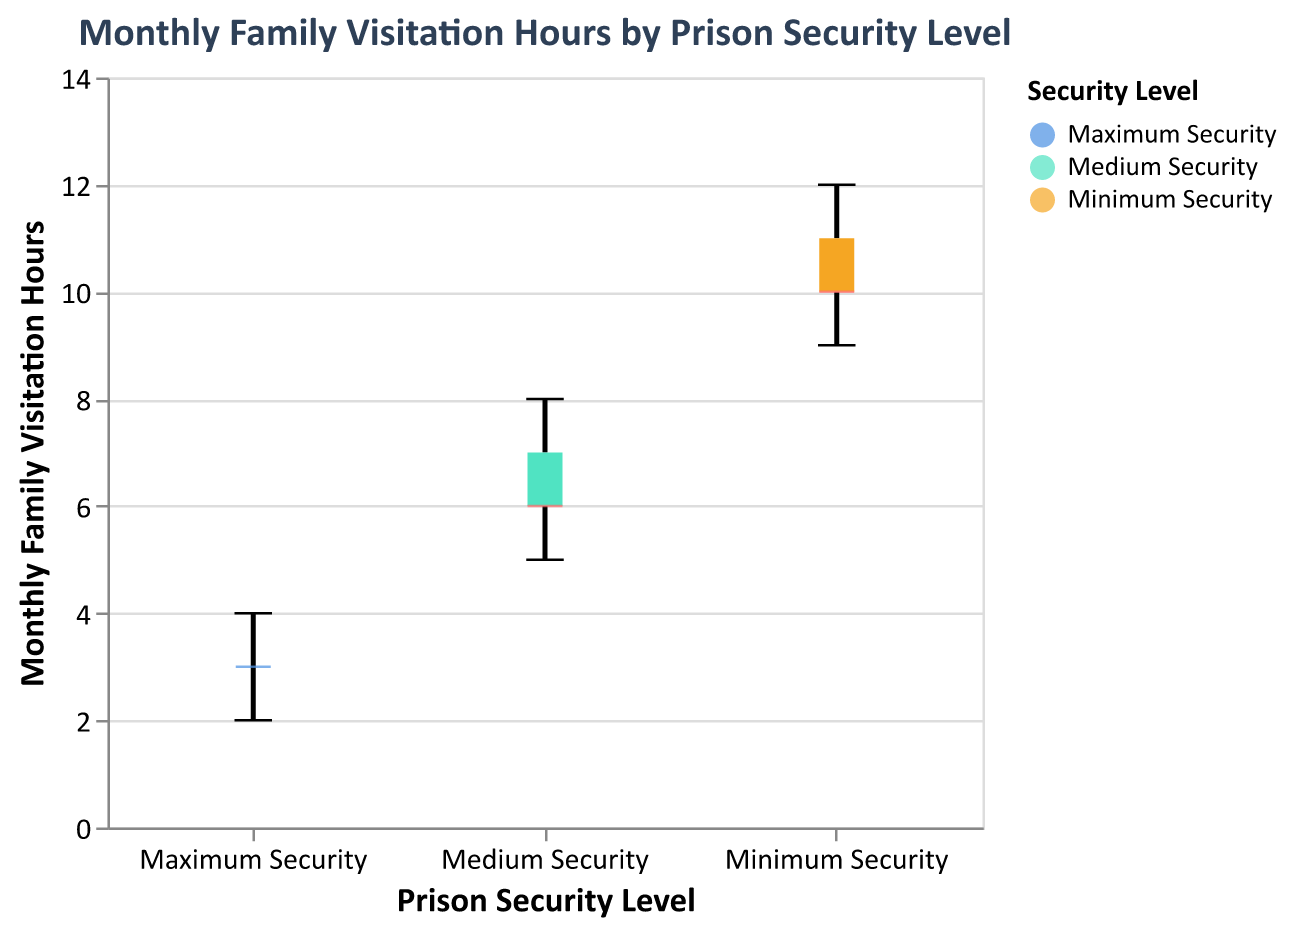What is the median family visitation hours for Medium Security prisons? The median is shown as a distinct marker in the middle of each box. For Medium Security, the median visitation hours are at the marked position within the box plot.
Answer: 6 Which security level has the greatest range of family visitation hours? The range can be determined by looking at the vertical span of each box plot from minimum to maximum values. Minimum Security spans from 9 to 12, Medium Security from 5 to 8, and Maximum Security from 2 to 4. Thus, Minimum Security has the greatest range.
Answer: Minimum Security Is there any overlap in the family visitation hours between Medium and Minimum Security prisons? By examining the notches in the box plots, if the notches overlap, there is a potential overlap in the data distributions. Both Medium and Minimum Security notches do overlap, indicating potential overlap.
Answer: Yes Which security level has the highest median family visitation hours? The median for each security level is identified by the distinct markers within each box plot. Minimum Security has the highest median compared to Medium and Maximum Security.
Answer: Minimum Security How many data points represent family visitation hours for Maximum Security prisons? Each whisker box represents the distribution of several recorded data points. Counting the individual lines representing the data in the Maximum Security box plot, there are five points.
Answer: Five What is the lowest recorded family visitation hours across all security levels? The lowest value can be noted as the minimum point on the y-axis across all box plots. The lowest value shown in the Maximum Security box plot is the lowest across all security levels.
Answer: Two Compare the median family visitation hours between Maximum and Medium Security prisons. The median for Maximum Security is observed at 3, while the median for Medium Security is observed at 6 by examining the markers inside each box plot.
Answer: Medium Security > Maximum Security What is the interquartile range (IQR) for Minimum Security prisons? The IQR is the range between the first and third quartiles, which are the edges of the box. For Minimum Security, it spans from 9 to 11. Therefore, IQR = 11 - 9.
Answer: 2 